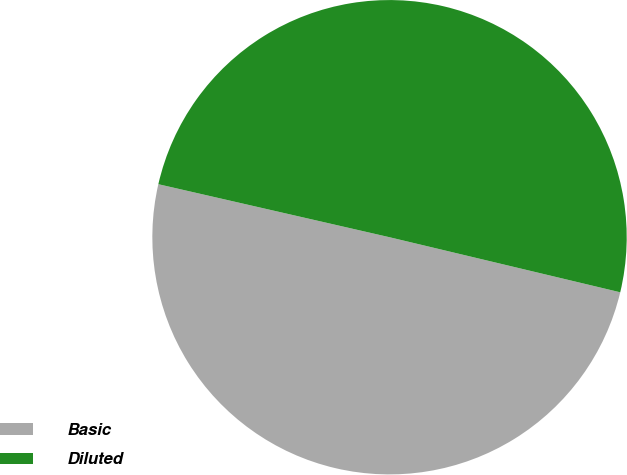<chart> <loc_0><loc_0><loc_500><loc_500><pie_chart><fcel>Basic<fcel>Diluted<nl><fcel>49.86%<fcel>50.14%<nl></chart> 